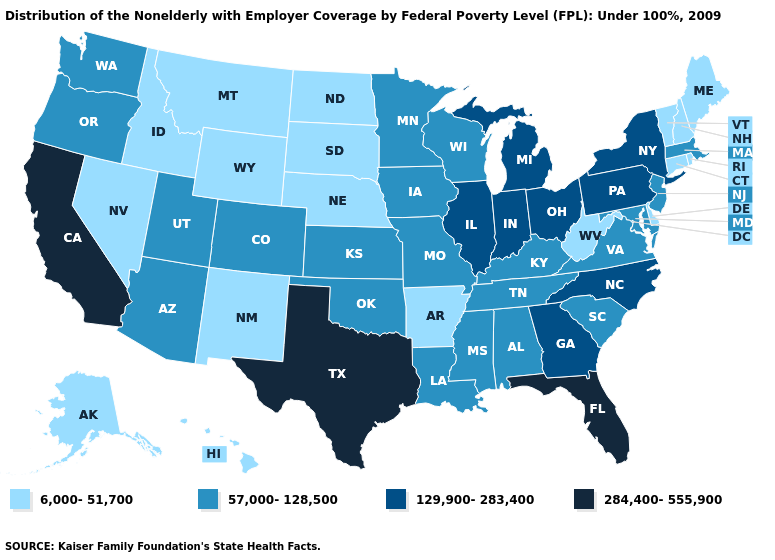Name the states that have a value in the range 129,900-283,400?
Quick response, please. Georgia, Illinois, Indiana, Michigan, New York, North Carolina, Ohio, Pennsylvania. Name the states that have a value in the range 129,900-283,400?
Write a very short answer. Georgia, Illinois, Indiana, Michigan, New York, North Carolina, Ohio, Pennsylvania. Which states hav the highest value in the South?
Keep it brief. Florida, Texas. Is the legend a continuous bar?
Be succinct. No. What is the value of Tennessee?
Give a very brief answer. 57,000-128,500. Name the states that have a value in the range 284,400-555,900?
Keep it brief. California, Florida, Texas. What is the highest value in the USA?
Answer briefly. 284,400-555,900. What is the lowest value in the USA?
Write a very short answer. 6,000-51,700. Among the states that border Arkansas , which have the highest value?
Give a very brief answer. Texas. Does Alabama have the lowest value in the South?
Keep it brief. No. Does the map have missing data?
Concise answer only. No. Name the states that have a value in the range 57,000-128,500?
Answer briefly. Alabama, Arizona, Colorado, Iowa, Kansas, Kentucky, Louisiana, Maryland, Massachusetts, Minnesota, Mississippi, Missouri, New Jersey, Oklahoma, Oregon, South Carolina, Tennessee, Utah, Virginia, Washington, Wisconsin. What is the value of Virginia?
Short answer required. 57,000-128,500. Does the map have missing data?
Give a very brief answer. No. What is the highest value in states that border Florida?
Quick response, please. 129,900-283,400. 